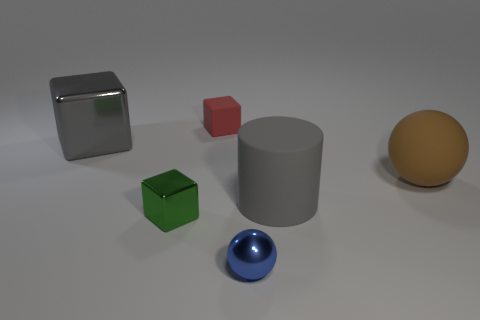Subtract all large cubes. How many cubes are left? 2 Add 3 tiny red matte blocks. How many objects exist? 9 Subtract all green cubes. How many cubes are left? 2 Subtract 1 balls. How many balls are left? 1 Add 2 green metallic cubes. How many green metallic cubes exist? 3 Subtract 0 cyan balls. How many objects are left? 6 Subtract all balls. How many objects are left? 4 Subtract all yellow spheres. Subtract all yellow blocks. How many spheres are left? 2 Subtract all shiny things. Subtract all tiny blue metal things. How many objects are left? 2 Add 4 small spheres. How many small spheres are left? 5 